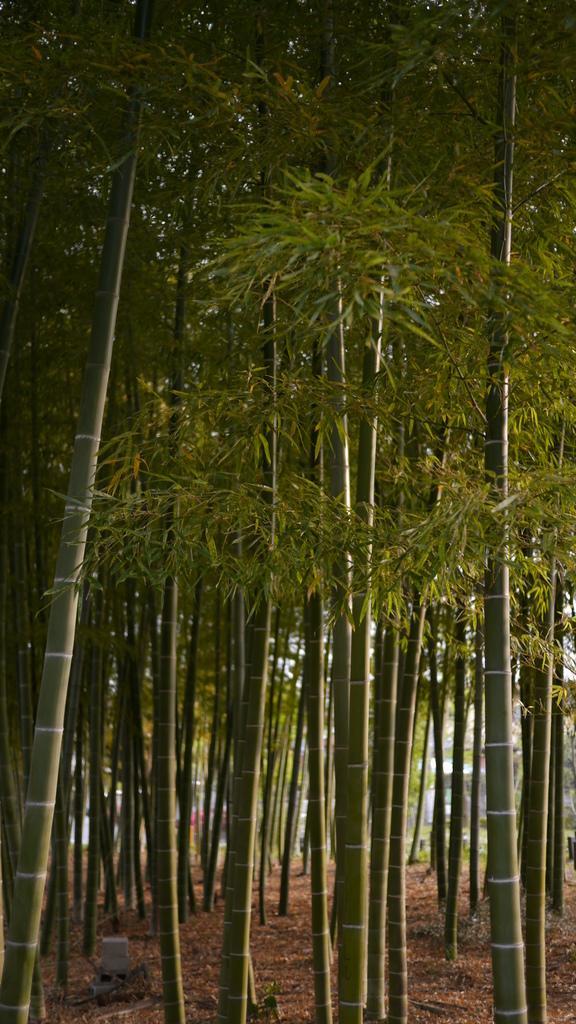Can you describe this image briefly? In this image, I can see the bamboo trees with the leaves. This looks like an object, which is placed on the ground. 